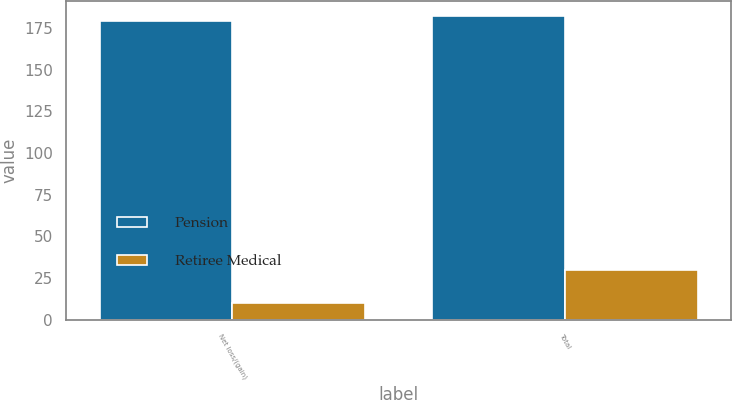<chart> <loc_0><loc_0><loc_500><loc_500><stacked_bar_chart><ecel><fcel>Net loss/(gain)<fcel>Total<nl><fcel>Pension<fcel>179<fcel>182<nl><fcel>Retiree Medical<fcel>10<fcel>30<nl></chart> 